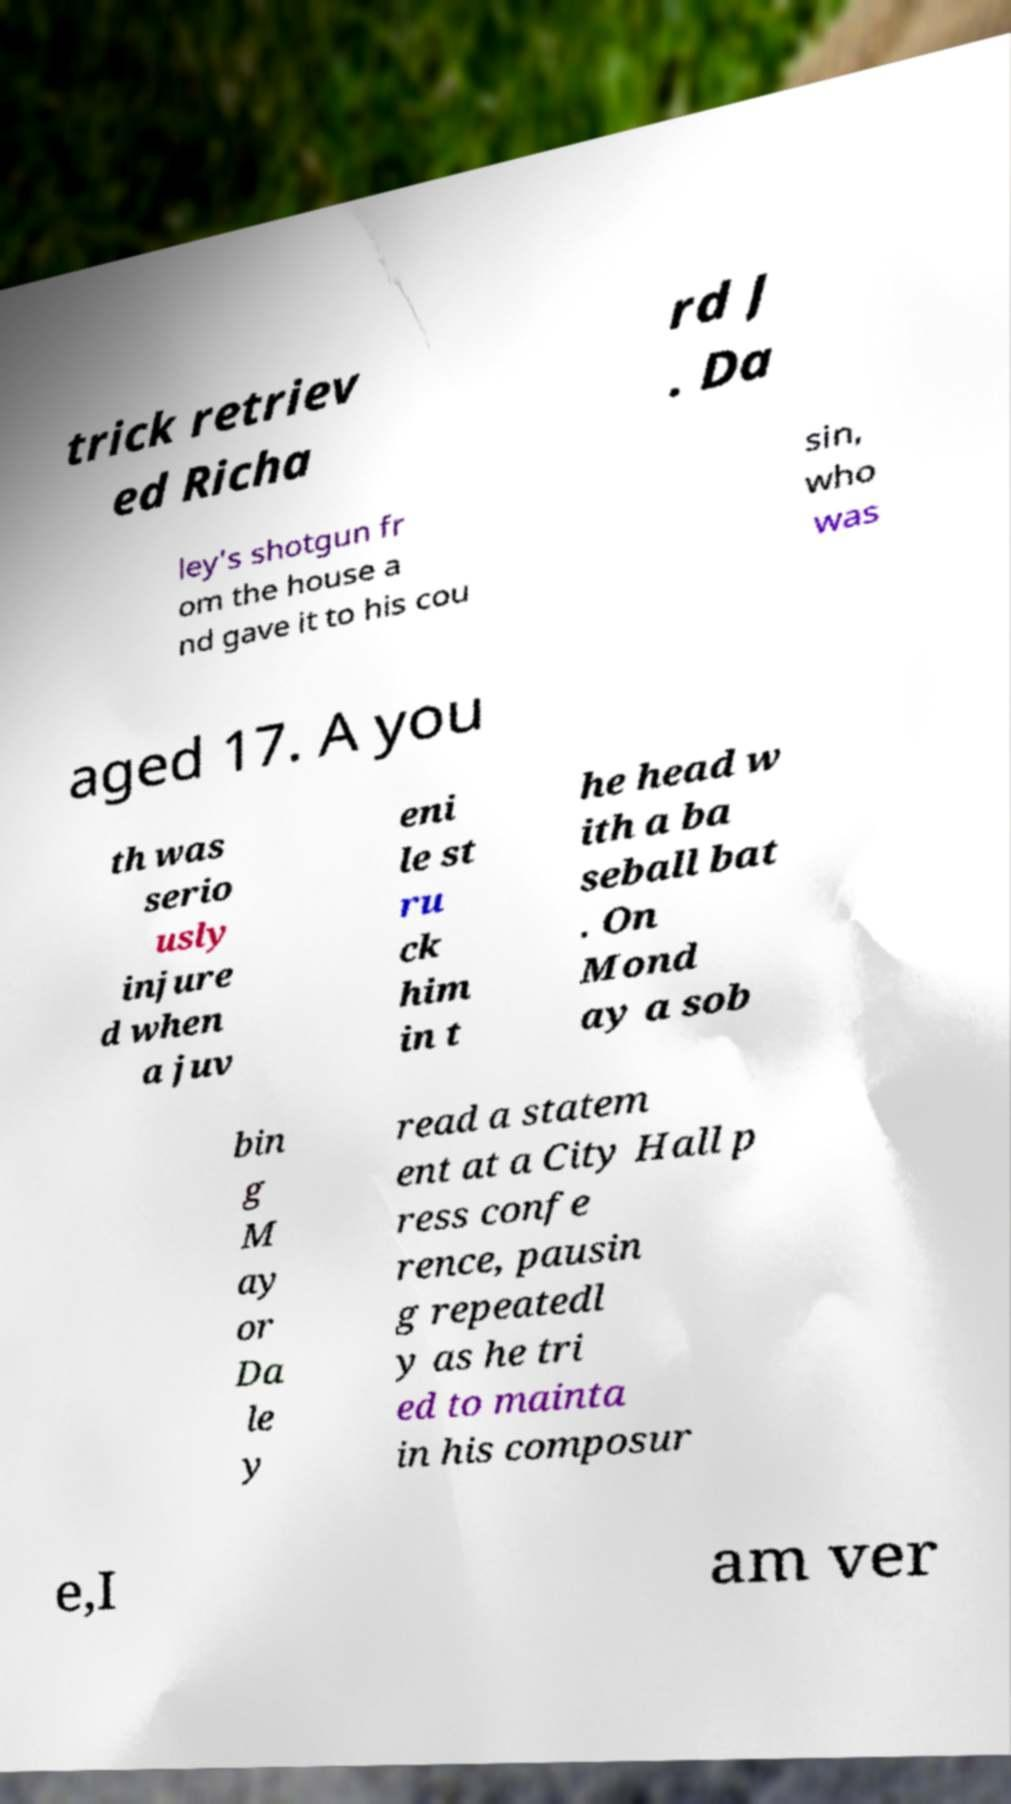There's text embedded in this image that I need extracted. Can you transcribe it verbatim? trick retriev ed Richa rd J . Da ley's shotgun fr om the house a nd gave it to his cou sin, who was aged 17. A you th was serio usly injure d when a juv eni le st ru ck him in t he head w ith a ba seball bat . On Mond ay a sob bin g M ay or Da le y read a statem ent at a City Hall p ress confe rence, pausin g repeatedl y as he tri ed to mainta in his composur e,I am ver 